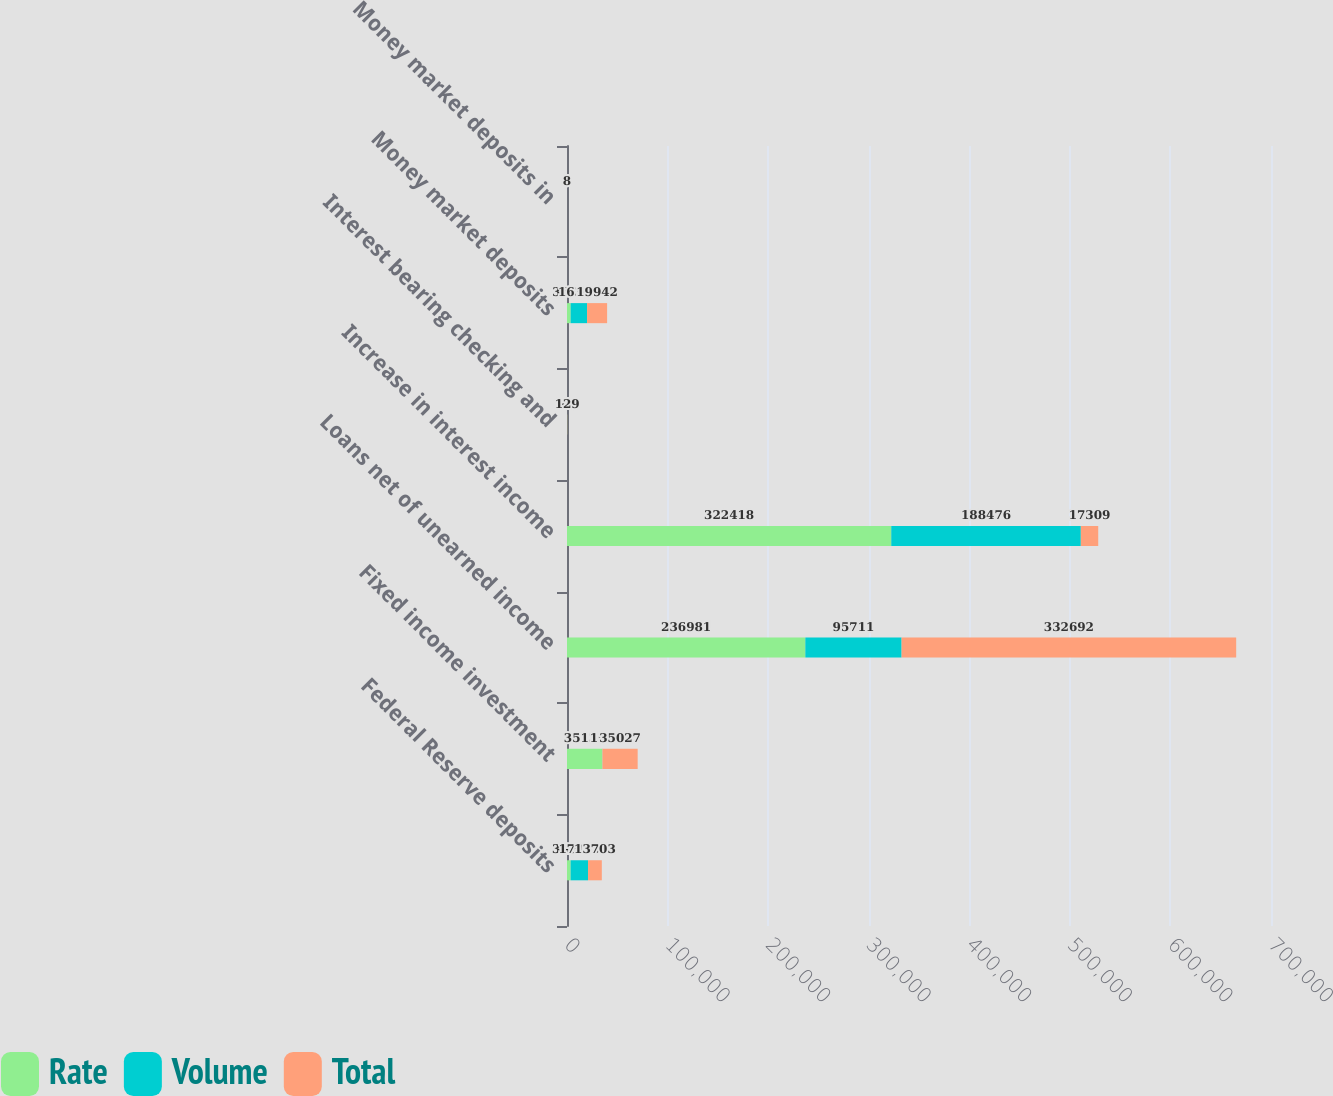<chart> <loc_0><loc_0><loc_500><loc_500><stacked_bar_chart><ecel><fcel>Federal Reserve deposits<fcel>Fixed income investment<fcel>Loans net of unearned income<fcel>Increase in interest income<fcel>Interest bearing checking and<fcel>Money market deposits<fcel>Money market deposits in<nl><fcel>Rate<fcel>3606<fcel>35132<fcel>236981<fcel>322418<fcel>118<fcel>3634<fcel>5<nl><fcel>Volume<fcel>17309<fcel>105<fcel>95711<fcel>188476<fcel>11<fcel>16308<fcel>3<nl><fcel>Total<fcel>13703<fcel>35027<fcel>332692<fcel>17309<fcel>129<fcel>19942<fcel>8<nl></chart> 